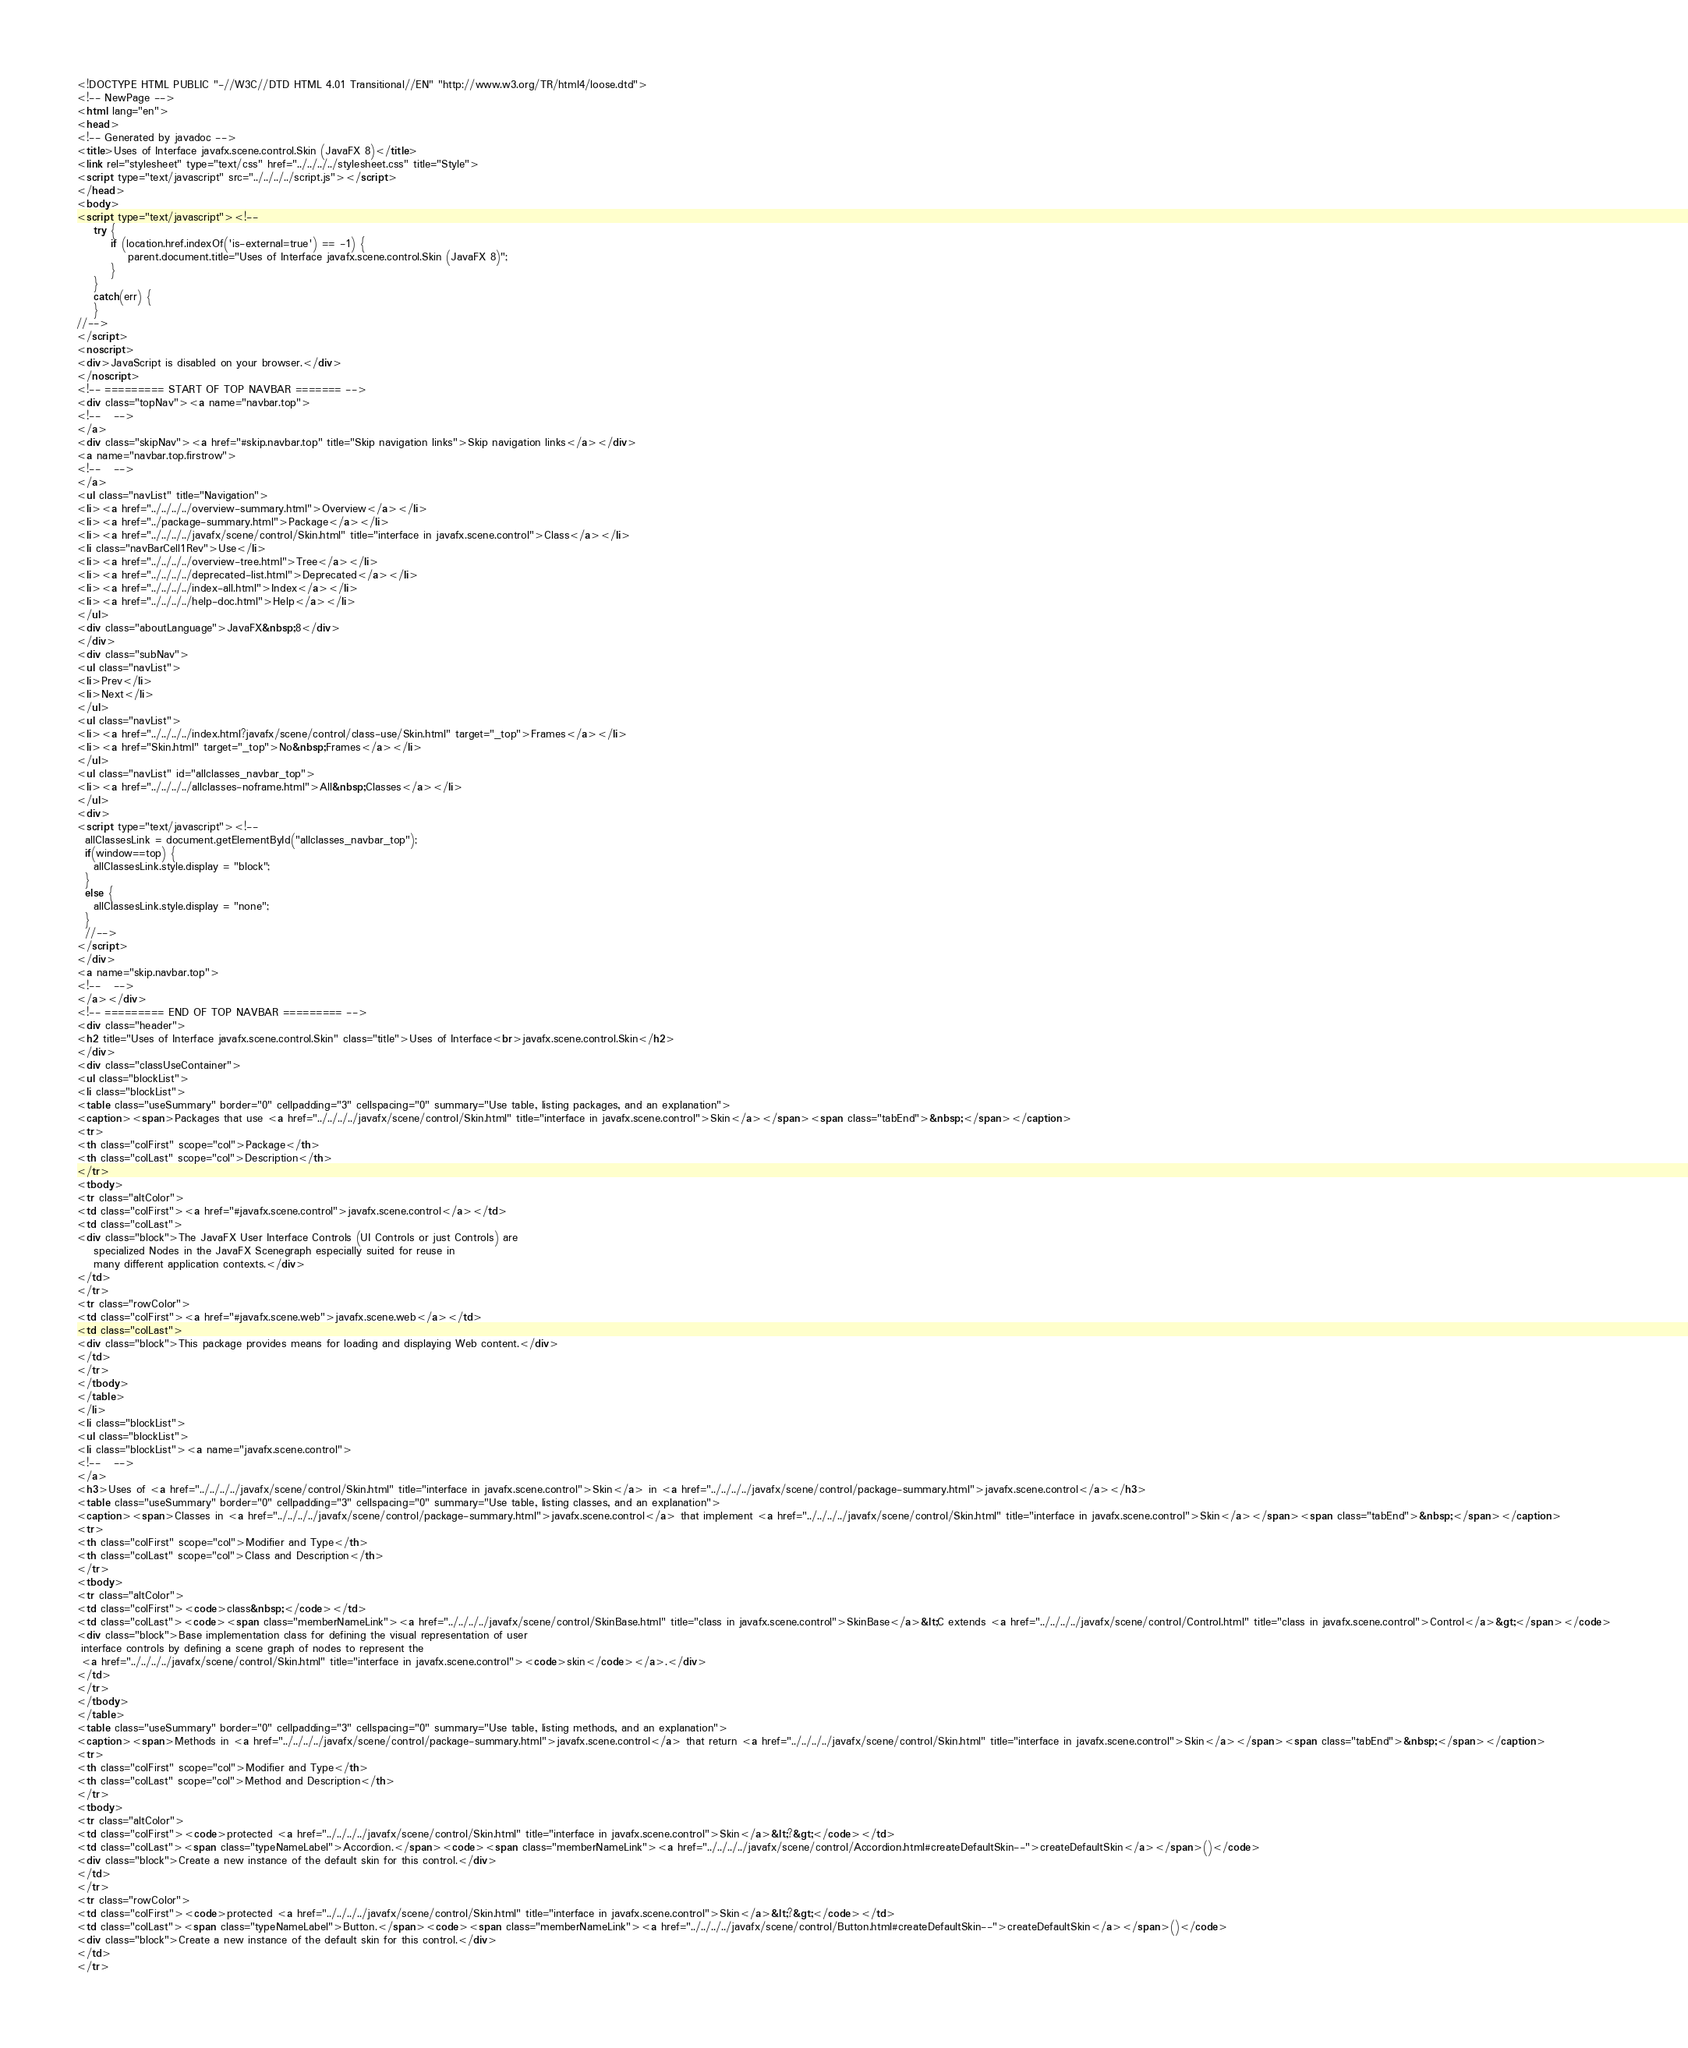Convert code to text. <code><loc_0><loc_0><loc_500><loc_500><_HTML_><!DOCTYPE HTML PUBLIC "-//W3C//DTD HTML 4.01 Transitional//EN" "http://www.w3.org/TR/html4/loose.dtd">
<!-- NewPage -->
<html lang="en">
<head>
<!-- Generated by javadoc -->
<title>Uses of Interface javafx.scene.control.Skin (JavaFX 8)</title>
<link rel="stylesheet" type="text/css" href="../../../../stylesheet.css" title="Style">
<script type="text/javascript" src="../../../../script.js"></script>
</head>
<body>
<script type="text/javascript"><!--
    try {
        if (location.href.indexOf('is-external=true') == -1) {
            parent.document.title="Uses of Interface javafx.scene.control.Skin (JavaFX 8)";
        }
    }
    catch(err) {
    }
//-->
</script>
<noscript>
<div>JavaScript is disabled on your browser.</div>
</noscript>
<!-- ========= START OF TOP NAVBAR ======= -->
<div class="topNav"><a name="navbar.top">
<!--   -->
</a>
<div class="skipNav"><a href="#skip.navbar.top" title="Skip navigation links">Skip navigation links</a></div>
<a name="navbar.top.firstrow">
<!--   -->
</a>
<ul class="navList" title="Navigation">
<li><a href="../../../../overview-summary.html">Overview</a></li>
<li><a href="../package-summary.html">Package</a></li>
<li><a href="../../../../javafx/scene/control/Skin.html" title="interface in javafx.scene.control">Class</a></li>
<li class="navBarCell1Rev">Use</li>
<li><a href="../../../../overview-tree.html">Tree</a></li>
<li><a href="../../../../deprecated-list.html">Deprecated</a></li>
<li><a href="../../../../index-all.html">Index</a></li>
<li><a href="../../../../help-doc.html">Help</a></li>
</ul>
<div class="aboutLanguage">JavaFX&nbsp;8</div>
</div>
<div class="subNav">
<ul class="navList">
<li>Prev</li>
<li>Next</li>
</ul>
<ul class="navList">
<li><a href="../../../../index.html?javafx/scene/control/class-use/Skin.html" target="_top">Frames</a></li>
<li><a href="Skin.html" target="_top">No&nbsp;Frames</a></li>
</ul>
<ul class="navList" id="allclasses_navbar_top">
<li><a href="../../../../allclasses-noframe.html">All&nbsp;Classes</a></li>
</ul>
<div>
<script type="text/javascript"><!--
  allClassesLink = document.getElementById("allclasses_navbar_top");
  if(window==top) {
    allClassesLink.style.display = "block";
  }
  else {
    allClassesLink.style.display = "none";
  }
  //-->
</script>
</div>
<a name="skip.navbar.top">
<!--   -->
</a></div>
<!-- ========= END OF TOP NAVBAR ========= -->
<div class="header">
<h2 title="Uses of Interface javafx.scene.control.Skin" class="title">Uses of Interface<br>javafx.scene.control.Skin</h2>
</div>
<div class="classUseContainer">
<ul class="blockList">
<li class="blockList">
<table class="useSummary" border="0" cellpadding="3" cellspacing="0" summary="Use table, listing packages, and an explanation">
<caption><span>Packages that use <a href="../../../../javafx/scene/control/Skin.html" title="interface in javafx.scene.control">Skin</a></span><span class="tabEnd">&nbsp;</span></caption>
<tr>
<th class="colFirst" scope="col">Package</th>
<th class="colLast" scope="col">Description</th>
</tr>
<tbody>
<tr class="altColor">
<td class="colFirst"><a href="#javafx.scene.control">javafx.scene.control</a></td>
<td class="colLast">
<div class="block">The JavaFX User Interface Controls (UI Controls or just Controls) are
    specialized Nodes in the JavaFX Scenegraph especially suited for reuse in
    many different application contexts.</div>
</td>
</tr>
<tr class="rowColor">
<td class="colFirst"><a href="#javafx.scene.web">javafx.scene.web</a></td>
<td class="colLast">
<div class="block">This package provides means for loading and displaying Web content.</div>
</td>
</tr>
</tbody>
</table>
</li>
<li class="blockList">
<ul class="blockList">
<li class="blockList"><a name="javafx.scene.control">
<!--   -->
</a>
<h3>Uses of <a href="../../../../javafx/scene/control/Skin.html" title="interface in javafx.scene.control">Skin</a> in <a href="../../../../javafx/scene/control/package-summary.html">javafx.scene.control</a></h3>
<table class="useSummary" border="0" cellpadding="3" cellspacing="0" summary="Use table, listing classes, and an explanation">
<caption><span>Classes in <a href="../../../../javafx/scene/control/package-summary.html">javafx.scene.control</a> that implement <a href="../../../../javafx/scene/control/Skin.html" title="interface in javafx.scene.control">Skin</a></span><span class="tabEnd">&nbsp;</span></caption>
<tr>
<th class="colFirst" scope="col">Modifier and Type</th>
<th class="colLast" scope="col">Class and Description</th>
</tr>
<tbody>
<tr class="altColor">
<td class="colFirst"><code>class&nbsp;</code></td>
<td class="colLast"><code><span class="memberNameLink"><a href="../../../../javafx/scene/control/SkinBase.html" title="class in javafx.scene.control">SkinBase</a>&lt;C extends <a href="../../../../javafx/scene/control/Control.html" title="class in javafx.scene.control">Control</a>&gt;</span></code>
<div class="block">Base implementation class for defining the visual representation of user
 interface controls by defining a scene graph of nodes to represent the
 <a href="../../../../javafx/scene/control/Skin.html" title="interface in javafx.scene.control"><code>skin</code></a>.</div>
</td>
</tr>
</tbody>
</table>
<table class="useSummary" border="0" cellpadding="3" cellspacing="0" summary="Use table, listing methods, and an explanation">
<caption><span>Methods in <a href="../../../../javafx/scene/control/package-summary.html">javafx.scene.control</a> that return <a href="../../../../javafx/scene/control/Skin.html" title="interface in javafx.scene.control">Skin</a></span><span class="tabEnd">&nbsp;</span></caption>
<tr>
<th class="colFirst" scope="col">Modifier and Type</th>
<th class="colLast" scope="col">Method and Description</th>
</tr>
<tbody>
<tr class="altColor">
<td class="colFirst"><code>protected <a href="../../../../javafx/scene/control/Skin.html" title="interface in javafx.scene.control">Skin</a>&lt;?&gt;</code></td>
<td class="colLast"><span class="typeNameLabel">Accordion.</span><code><span class="memberNameLink"><a href="../../../../javafx/scene/control/Accordion.html#createDefaultSkin--">createDefaultSkin</a></span>()</code>
<div class="block">Create a new instance of the default skin for this control.</div>
</td>
</tr>
<tr class="rowColor">
<td class="colFirst"><code>protected <a href="../../../../javafx/scene/control/Skin.html" title="interface in javafx.scene.control">Skin</a>&lt;?&gt;</code></td>
<td class="colLast"><span class="typeNameLabel">Button.</span><code><span class="memberNameLink"><a href="../../../../javafx/scene/control/Button.html#createDefaultSkin--">createDefaultSkin</a></span>()</code>
<div class="block">Create a new instance of the default skin for this control.</div>
</td>
</tr></code> 